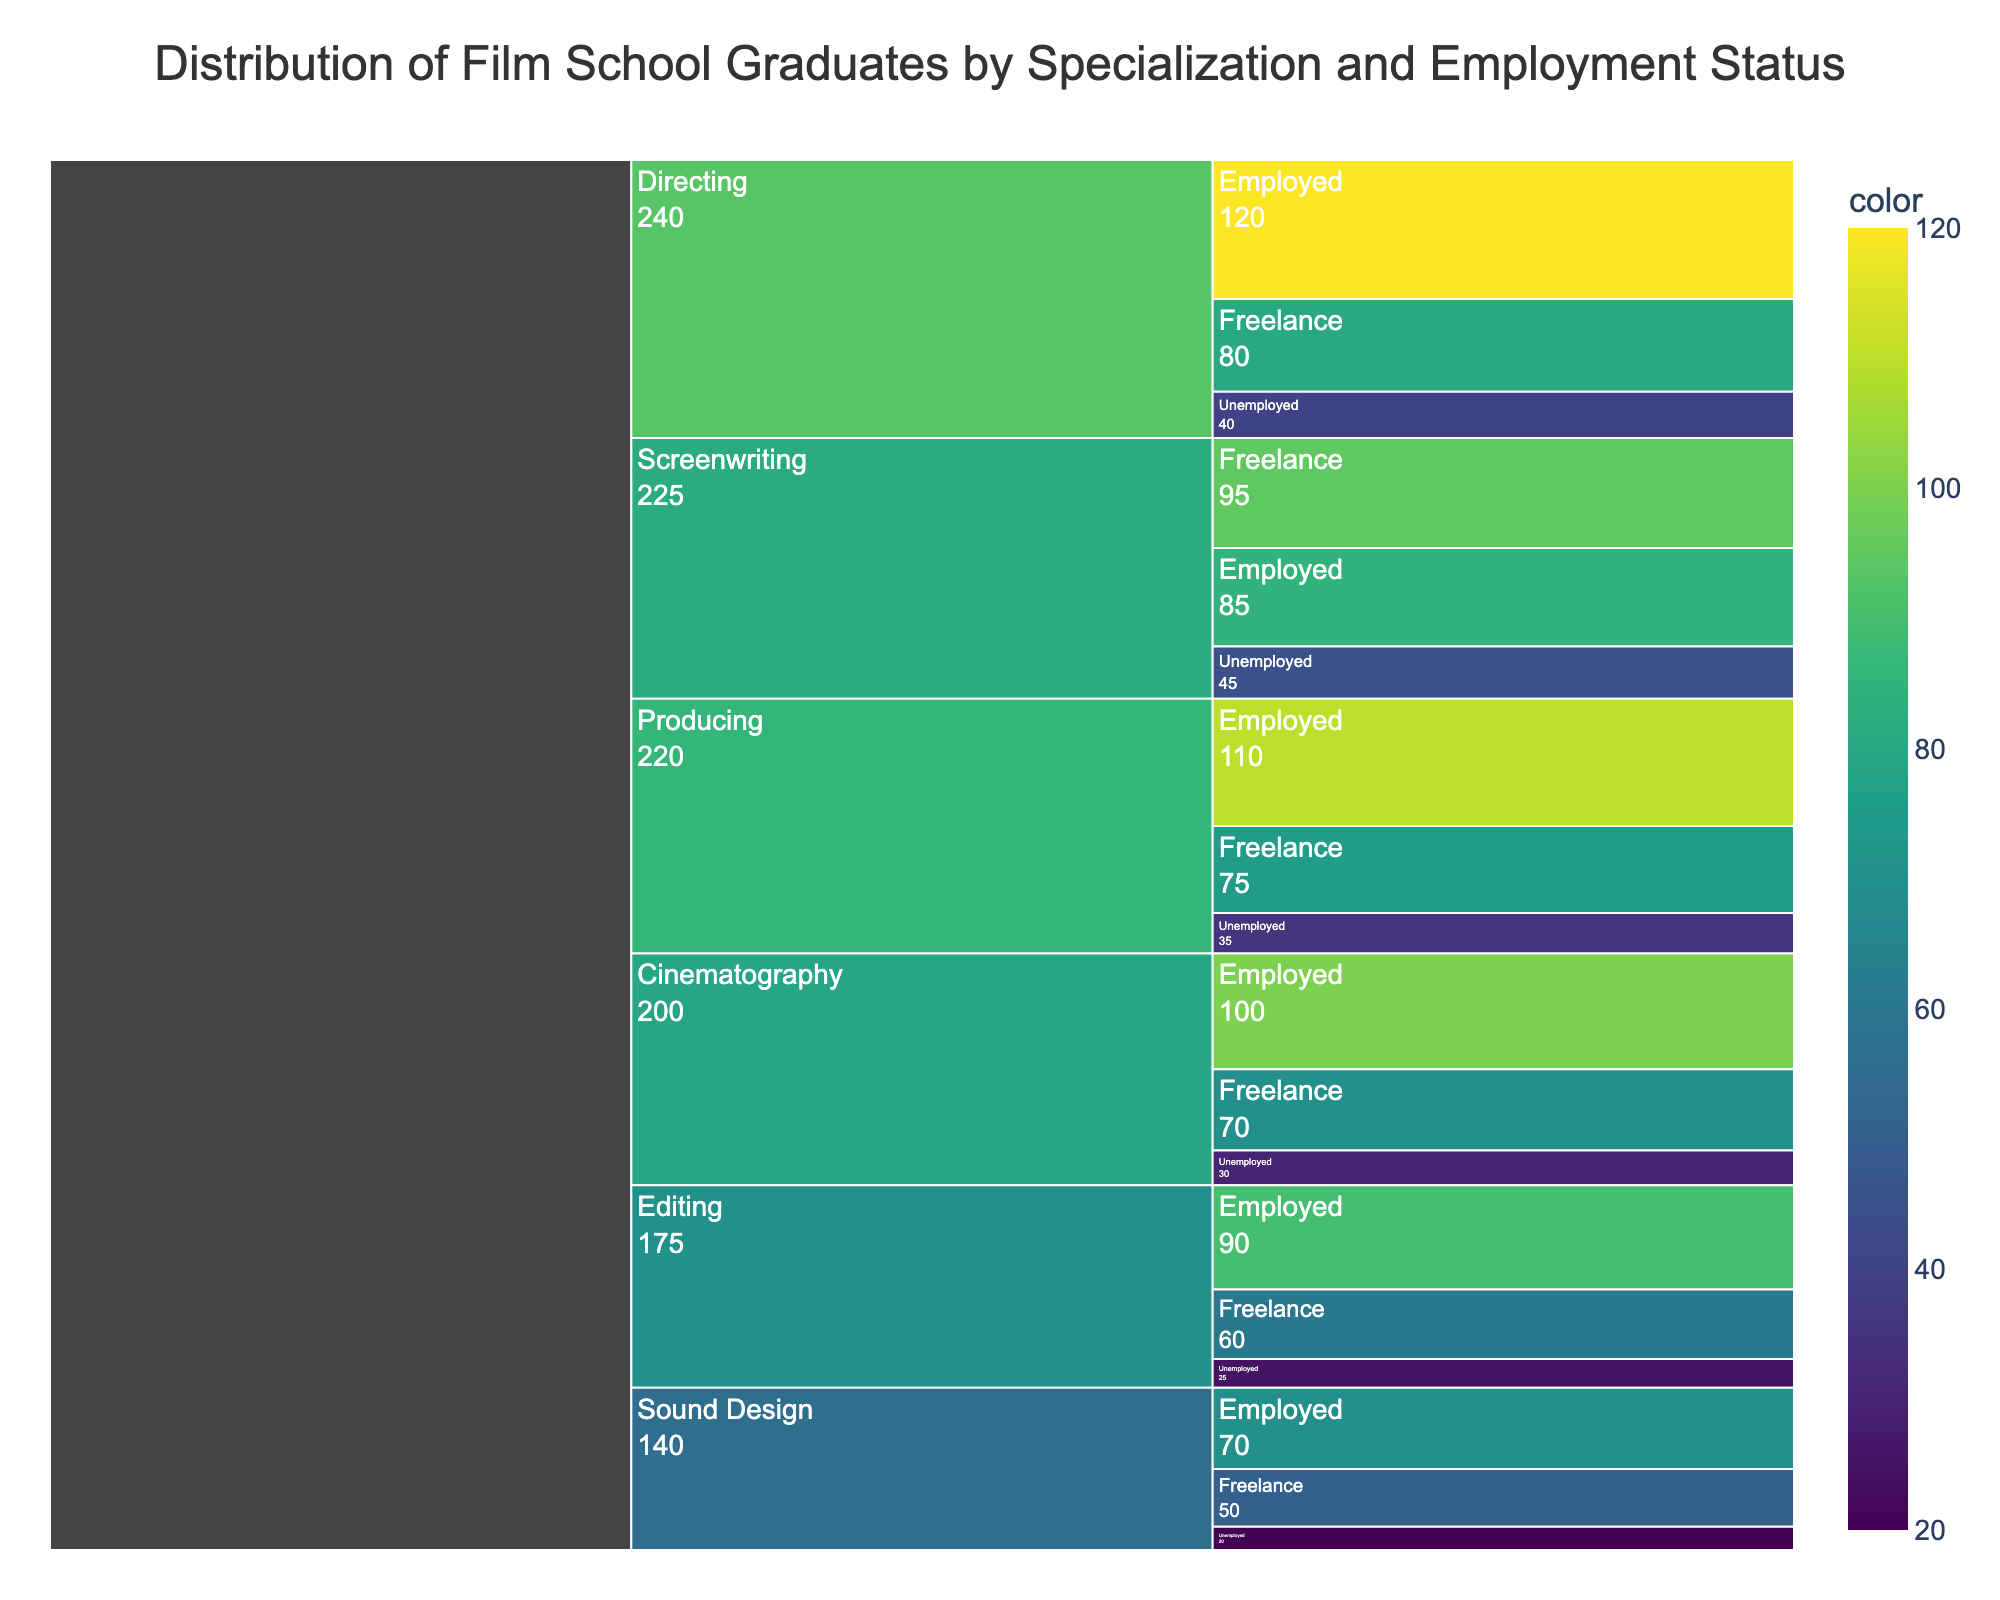What's the title of the chart? The title is located at the top of the chart and provides a concise summary of the figure's content. Here, it is "Distribution of Film School Graduates by Specialization and Employment Status".
Answer: Distribution of Film School Graduates by Specialization and Employment Status What's the total number of graduates in the directing specialization? Add the numbers of Employed, Freelance, and Unemployed graduates in Directing (120 + 80 + 40).
Answer: 240 Which specialization has the highest number of unemployed graduates? By comparing the number of unemployed graduates across all specializations, Screenwriting has the highest count (45).
Answer: Screenwriting How many more directing graduates are freelance compared to unemployed? Subtract the number of unemployed graduates in Directing (40) from the number of Freelance graduates in Directing (80).
Answer: 40 What is the combined number of employed graduates in Editing and Producing? Add the number of employed graduates in Editing (90) and Producing (110).
Answer: 200 Which specialization has the least number of employed graduates? By comparing the employed graduates across specializations, Sound Design has the lowest count (70).
Answer: Sound Design How does the number of freelance graduates in Cinematography compare to those in Producing? Compare the numbers: Cinematography (70) and Producing (75). Cinematography has fewer freelance graduates than Producing.
Answer: Cinematography has fewer What percentage of Screenwriting graduates are unemployed? Calculate the percentage by dividing the number of unemployed Screenwriting graduates (45) by the total number of Screenwriting graduates (85 + 95 + 45), then multiply by 100. (45 / 225) * 100 = 20%.
Answer: 20% Which specialization has the highest overall number of graduates? Sum all the graduates (employed, freelance, and unemployed) for each specialization and compare the totals. Directing has the highest total (240).
Answer: Directing What is the difference between the total number of freelance graduates and unemployed graduates across all specializations? Sum the number of freelance graduates and subtract the sum of unemployed graduates. Sum of Freelance (430) and Sum of Unemployed (195). Difference = 430 - 195 = 235.
Answer: 235 